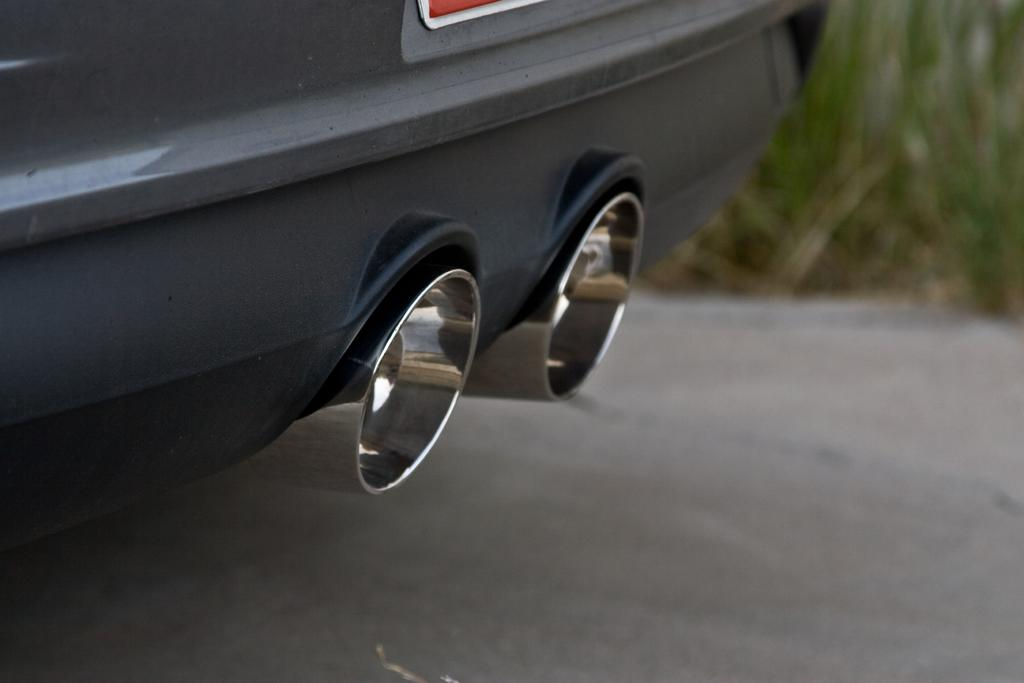What is the main subject of the image? The main subject of the image is the tailpipes of a vehicle. Can you describe the background of the image? The background of the image is blurred. What type of channel can be seen in the image? There is no channel present in the image; it features the tailpipes of a vehicle and a blurred background. How many tomatoes are visible in the image? There are no tomatoes present in the image. 